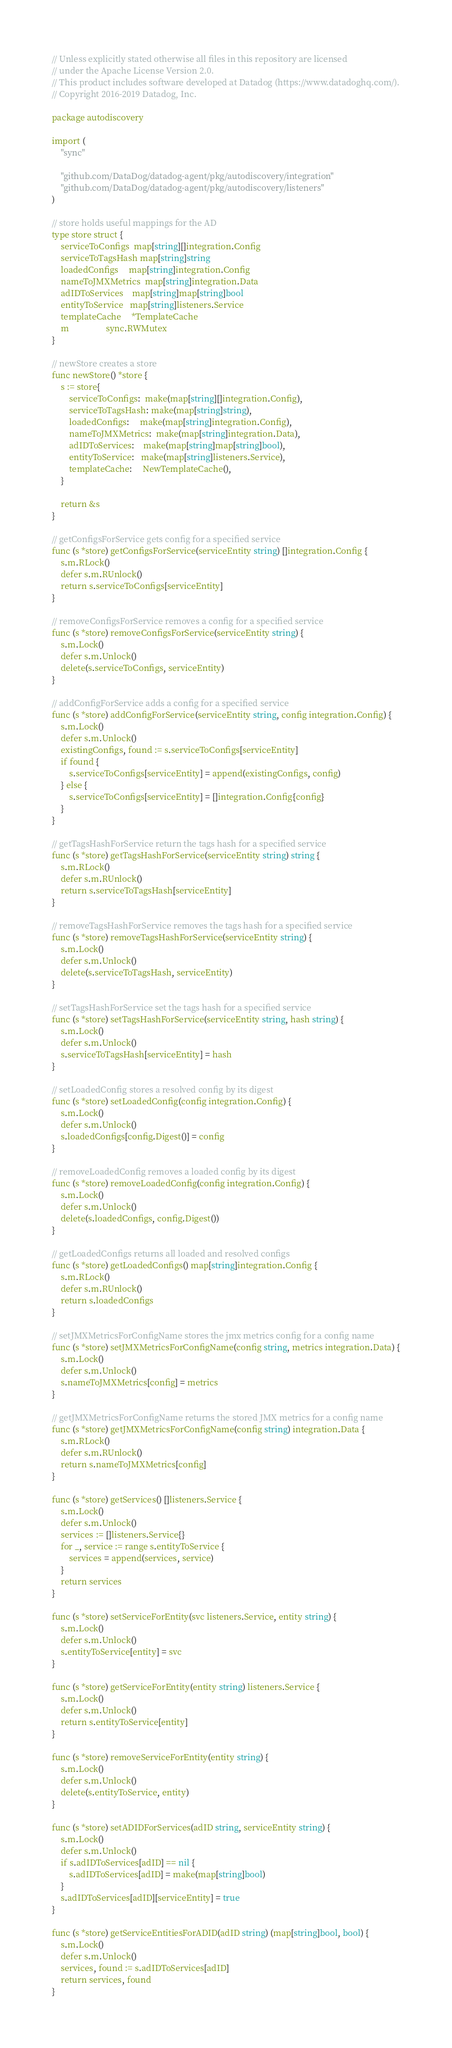<code> <loc_0><loc_0><loc_500><loc_500><_Go_>// Unless explicitly stated otherwise all files in this repository are licensed
// under the Apache License Version 2.0.
// This product includes software developed at Datadog (https://www.datadoghq.com/).
// Copyright 2016-2019 Datadog, Inc.

package autodiscovery

import (
	"sync"

	"github.com/DataDog/datadog-agent/pkg/autodiscovery/integration"
	"github.com/DataDog/datadog-agent/pkg/autodiscovery/listeners"
)

// store holds useful mappings for the AD
type store struct {
	serviceToConfigs  map[string][]integration.Config
	serviceToTagsHash map[string]string
	loadedConfigs     map[string]integration.Config
	nameToJMXMetrics  map[string]integration.Data
	adIDToServices    map[string]map[string]bool
	entityToService   map[string]listeners.Service
	templateCache     *TemplateCache
	m                 sync.RWMutex
}

// newStore creates a store
func newStore() *store {
	s := store{
		serviceToConfigs:  make(map[string][]integration.Config),
		serviceToTagsHash: make(map[string]string),
		loadedConfigs:     make(map[string]integration.Config),
		nameToJMXMetrics:  make(map[string]integration.Data),
		adIDToServices:    make(map[string]map[string]bool),
		entityToService:   make(map[string]listeners.Service),
		templateCache:     NewTemplateCache(),
	}

	return &s
}

// getConfigsForService gets config for a specified service
func (s *store) getConfigsForService(serviceEntity string) []integration.Config {
	s.m.RLock()
	defer s.m.RUnlock()
	return s.serviceToConfigs[serviceEntity]
}

// removeConfigsForService removes a config for a specified service
func (s *store) removeConfigsForService(serviceEntity string) {
	s.m.Lock()
	defer s.m.Unlock()
	delete(s.serviceToConfigs, serviceEntity)
}

// addConfigForService adds a config for a specified service
func (s *store) addConfigForService(serviceEntity string, config integration.Config) {
	s.m.Lock()
	defer s.m.Unlock()
	existingConfigs, found := s.serviceToConfigs[serviceEntity]
	if found {
		s.serviceToConfigs[serviceEntity] = append(existingConfigs, config)
	} else {
		s.serviceToConfigs[serviceEntity] = []integration.Config{config}
	}
}

// getTagsHashForService return the tags hash for a specified service
func (s *store) getTagsHashForService(serviceEntity string) string {
	s.m.RLock()
	defer s.m.RUnlock()
	return s.serviceToTagsHash[serviceEntity]
}

// removeTagsHashForService removes the tags hash for a specified service
func (s *store) removeTagsHashForService(serviceEntity string) {
	s.m.Lock()
	defer s.m.Unlock()
	delete(s.serviceToTagsHash, serviceEntity)
}

// setTagsHashForService set the tags hash for a specified service
func (s *store) setTagsHashForService(serviceEntity string, hash string) {
	s.m.Lock()
	defer s.m.Unlock()
	s.serviceToTagsHash[serviceEntity] = hash
}

// setLoadedConfig stores a resolved config by its digest
func (s *store) setLoadedConfig(config integration.Config) {
	s.m.Lock()
	defer s.m.Unlock()
	s.loadedConfigs[config.Digest()] = config
}

// removeLoadedConfig removes a loaded config by its digest
func (s *store) removeLoadedConfig(config integration.Config) {
	s.m.Lock()
	defer s.m.Unlock()
	delete(s.loadedConfigs, config.Digest())
}

// getLoadedConfigs returns all loaded and resolved configs
func (s *store) getLoadedConfigs() map[string]integration.Config {
	s.m.RLock()
	defer s.m.RUnlock()
	return s.loadedConfigs
}

// setJMXMetricsForConfigName stores the jmx metrics config for a config name
func (s *store) setJMXMetricsForConfigName(config string, metrics integration.Data) {
	s.m.Lock()
	defer s.m.Unlock()
	s.nameToJMXMetrics[config] = metrics
}

// getJMXMetricsForConfigName returns the stored JMX metrics for a config name
func (s *store) getJMXMetricsForConfigName(config string) integration.Data {
	s.m.RLock()
	defer s.m.RUnlock()
	return s.nameToJMXMetrics[config]
}

func (s *store) getServices() []listeners.Service {
	s.m.Lock()
	defer s.m.Unlock()
	services := []listeners.Service{}
	for _, service := range s.entityToService {
		services = append(services, service)
	}
	return services
}

func (s *store) setServiceForEntity(svc listeners.Service, entity string) {
	s.m.Lock()
	defer s.m.Unlock()
	s.entityToService[entity] = svc
}

func (s *store) getServiceForEntity(entity string) listeners.Service {
	s.m.Lock()
	defer s.m.Unlock()
	return s.entityToService[entity]
}

func (s *store) removeServiceForEntity(entity string) {
	s.m.Lock()
	defer s.m.Unlock()
	delete(s.entityToService, entity)
}

func (s *store) setADIDForServices(adID string, serviceEntity string) {
	s.m.Lock()
	defer s.m.Unlock()
	if s.adIDToServices[adID] == nil {
		s.adIDToServices[adID] = make(map[string]bool)
	}
	s.adIDToServices[adID][serviceEntity] = true
}

func (s *store) getServiceEntitiesForADID(adID string) (map[string]bool, bool) {
	s.m.Lock()
	defer s.m.Unlock()
	services, found := s.adIDToServices[adID]
	return services, found
}
</code> 